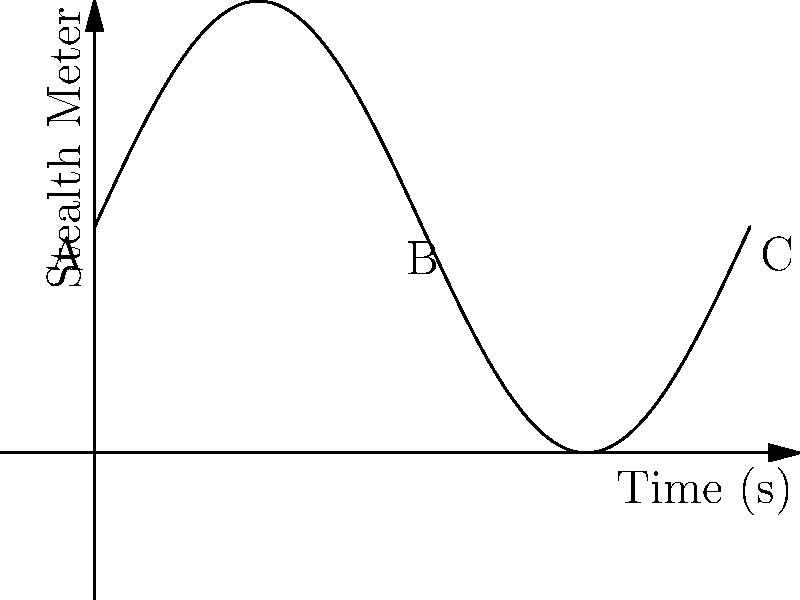In Assassin's Creed, the stealth meter fluctuates during gameplay, represented by the sinusoidal function $S(t)=5\sin(\frac{t}{2})+5$, where $S$ is the stealth level and $t$ is time in seconds. At which point (A, B, or C) is the rate of change of the stealth meter the highest in magnitude, and what is this maximum rate? To find the point with the highest rate of change in magnitude, we need to analyze the derivative of the stealth function:

1) The derivative of $S(t)$ is $S'(t) = 5 \cdot \frac{1}{2} \cos(\frac{t}{2}) = \frac{5}{2} \cos(\frac{t}{2})$

2) The magnitude of the rate of change is highest when $|\cos(\frac{t}{2})|$ is at its maximum, which occurs when $\cos(\frac{t}{2}) = \pm 1$

3) This happens at:
   Point A: $t = 0$, $\cos(0) = 1$
   Point B: $t = 2\pi$, $\cos(\pi) = -1$
   Point C: $t = 4\pi$, $\cos(2\pi) = 1$

4) At all these points, the magnitude of the rate of change is the same:
   $|S'(t)| = |\frac{5}{2} \cos(\frac{t}{2})| = \frac{5}{2}$

5) Therefore, the rate of change is highest in magnitude (2.5 units/second) at all three points A, B, and C.
Answer: All points (A, B, C); 2.5 units/second 